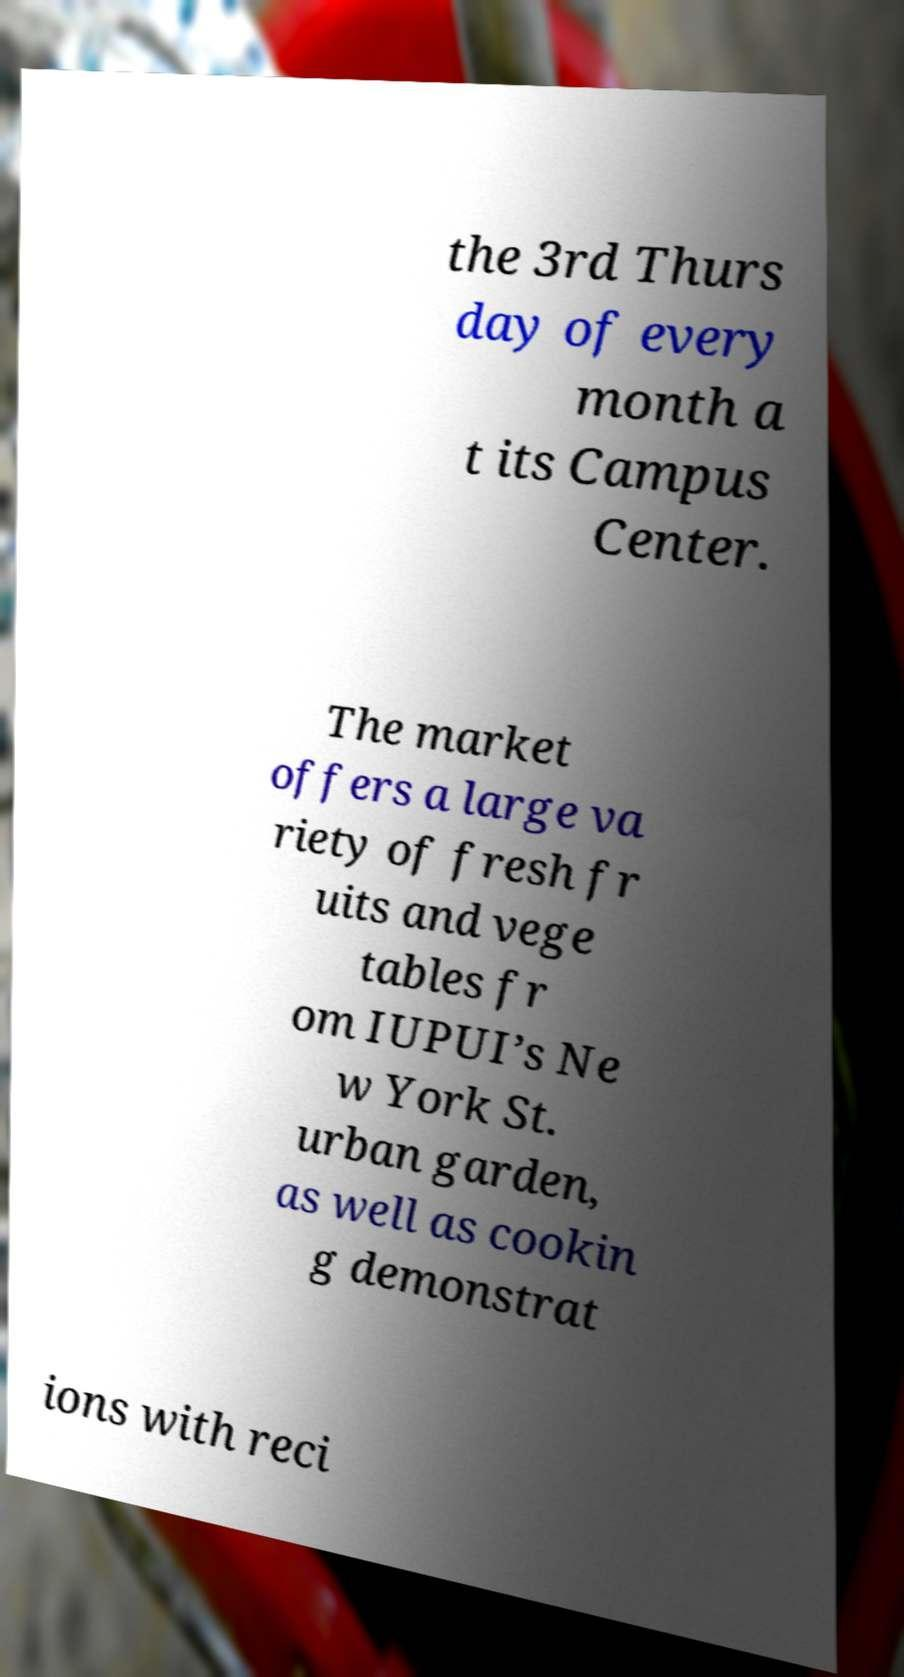Can you read and provide the text displayed in the image?This photo seems to have some interesting text. Can you extract and type it out for me? the 3rd Thurs day of every month a t its Campus Center. The market offers a large va riety of fresh fr uits and vege tables fr om IUPUI’s Ne w York St. urban garden, as well as cookin g demonstrat ions with reci 